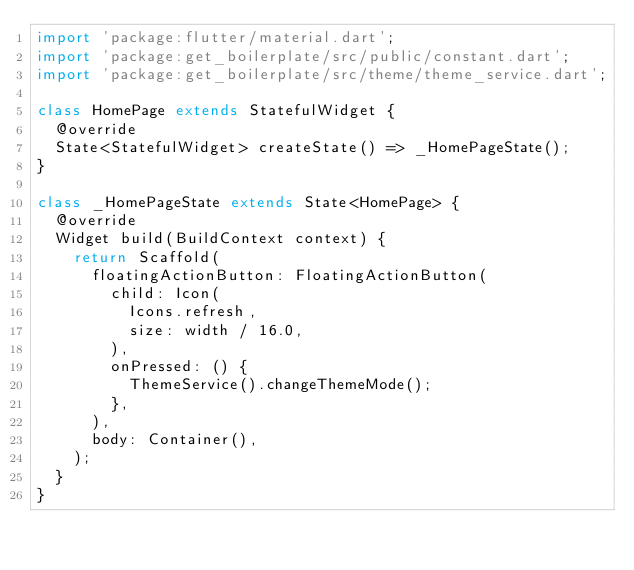Convert code to text. <code><loc_0><loc_0><loc_500><loc_500><_Dart_>import 'package:flutter/material.dart';
import 'package:get_boilerplate/src/public/constant.dart';
import 'package:get_boilerplate/src/theme/theme_service.dart';

class HomePage extends StatefulWidget {
  @override
  State<StatefulWidget> createState() => _HomePageState();
}

class _HomePageState extends State<HomePage> {
  @override
  Widget build(BuildContext context) {
    return Scaffold(
      floatingActionButton: FloatingActionButton(
        child: Icon(
          Icons.refresh,
          size: width / 16.0,
        ),
        onPressed: () {
          ThemeService().changeThemeMode();
        },
      ),
      body: Container(),
    );
  }
}
</code> 